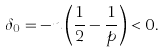Convert formula to latex. <formula><loc_0><loc_0><loc_500><loc_500>\delta _ { 0 } = - n \left ( \frac { 1 } { 2 } - \frac { 1 } { p } \right ) < 0 .</formula> 